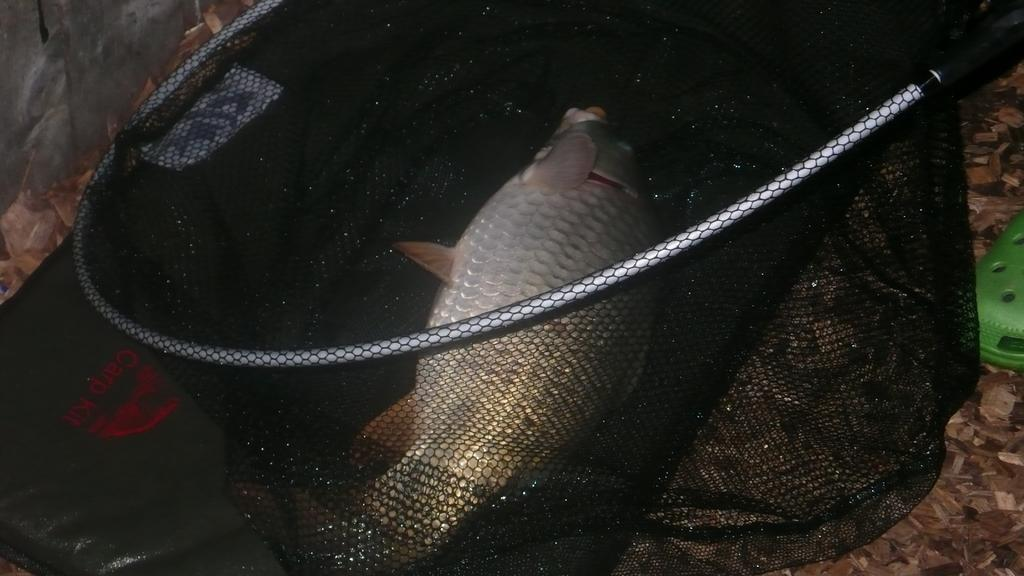What is the main object in the image? There is a black color net in the image. What is inside the net? There is a fish in the net. Where is the net located? The net is on the floor. What type of footwear can be seen on the right side of the image? There is color footwear on the right side of the image. What type of toy can be seen in the image? There is no toy present in the image. What shape is the breakfast depicted in the image? There is no breakfast depicted in the image. 